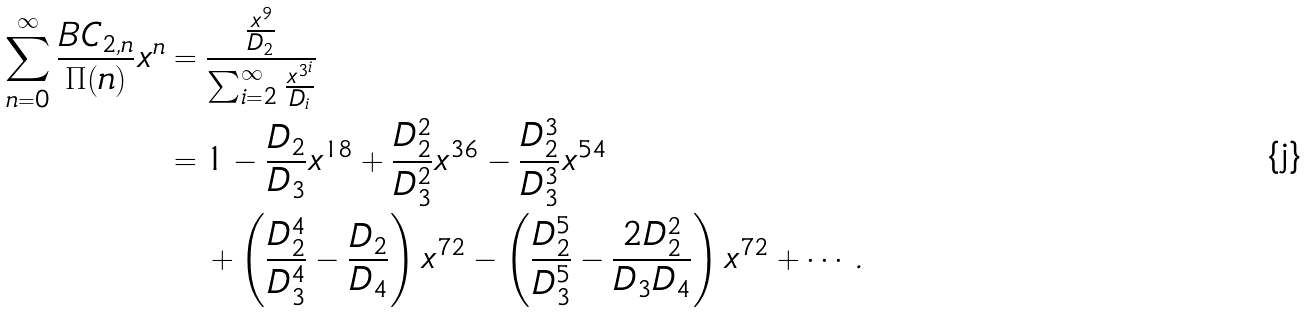<formula> <loc_0><loc_0><loc_500><loc_500>\sum _ { n = 0 } ^ { \infty } \frac { B C _ { 2 , n } } { \Pi ( n ) } x ^ { n } & = \frac { \frac { x ^ { 9 } } { D _ { 2 } } } { \sum _ { i = 2 } ^ { \infty } \frac { x ^ { 3 ^ { i } } } { D _ { i } } } \\ & = 1 - \frac { D _ { 2 } } { D _ { 3 } } x ^ { 1 8 } + \frac { D _ { 2 } ^ { 2 } } { D _ { 3 } ^ { 2 } } x ^ { 3 6 } - \frac { D _ { 2 } ^ { 3 } } { D _ { 3 } ^ { 3 } } x ^ { 5 4 } \\ & \quad + \left ( \frac { D _ { 2 } ^ { 4 } } { D _ { 3 } ^ { 4 } } - \frac { D _ { 2 } } { D _ { 4 } } \right ) x ^ { 7 2 } - \left ( \frac { D _ { 2 } ^ { 5 } } { D _ { 3 } ^ { 5 } } - \frac { 2 D _ { 2 } ^ { 2 } } { D _ { 3 } D _ { 4 } } \right ) x ^ { 7 2 } + \cdots \, .</formula> 